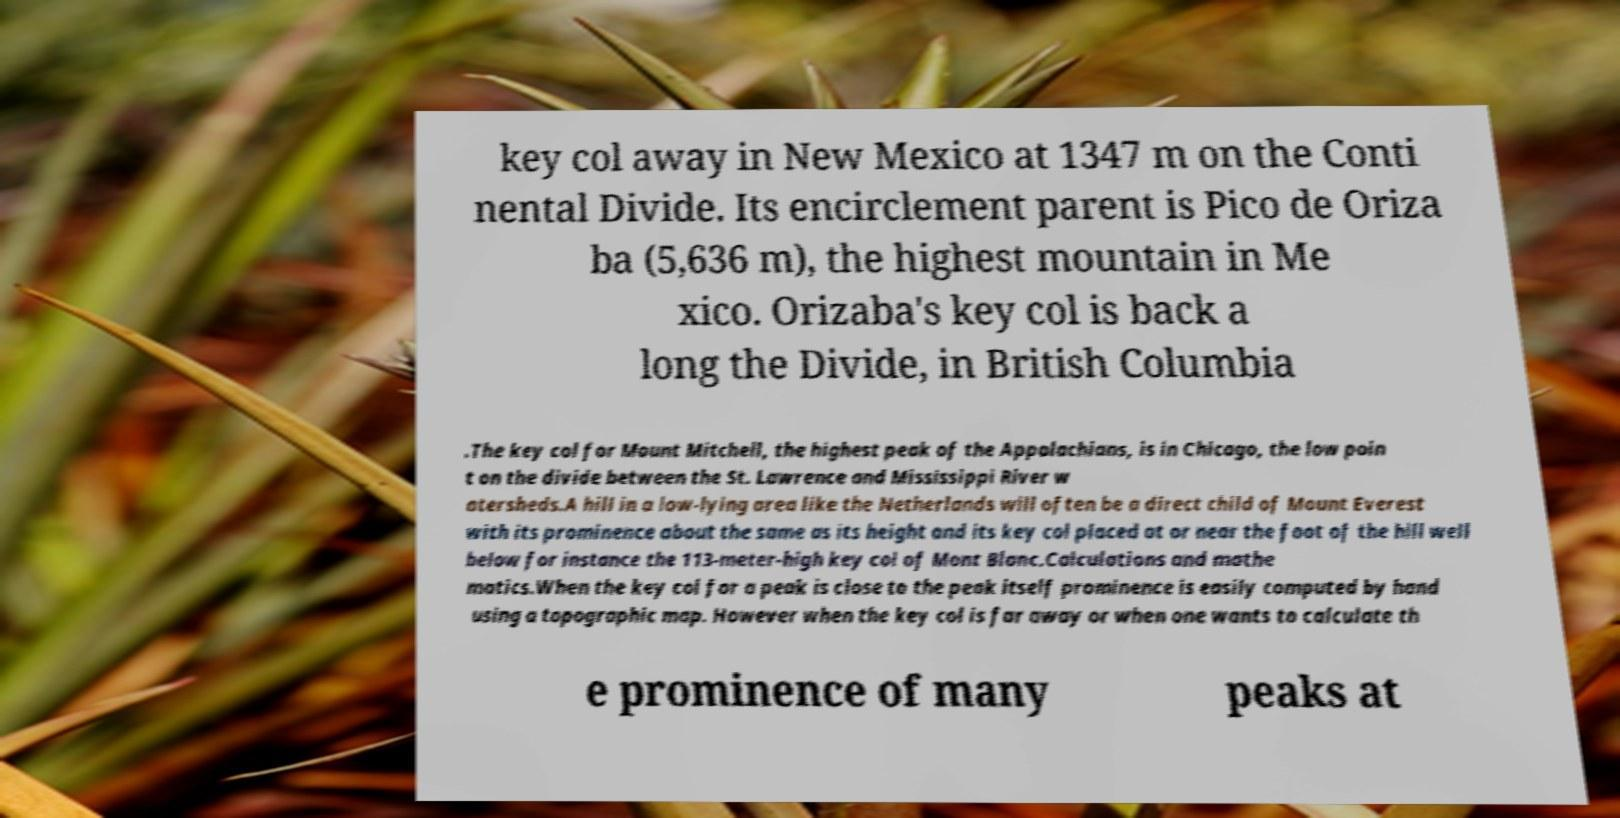Could you extract and type out the text from this image? key col away in New Mexico at 1347 m on the Conti nental Divide. Its encirclement parent is Pico de Oriza ba (5,636 m), the highest mountain in Me xico. Orizaba's key col is back a long the Divide, in British Columbia .The key col for Mount Mitchell, the highest peak of the Appalachians, is in Chicago, the low poin t on the divide between the St. Lawrence and Mississippi River w atersheds.A hill in a low-lying area like the Netherlands will often be a direct child of Mount Everest with its prominence about the same as its height and its key col placed at or near the foot of the hill well below for instance the 113-meter-high key col of Mont Blanc.Calculations and mathe matics.When the key col for a peak is close to the peak itself prominence is easily computed by hand using a topographic map. However when the key col is far away or when one wants to calculate th e prominence of many peaks at 